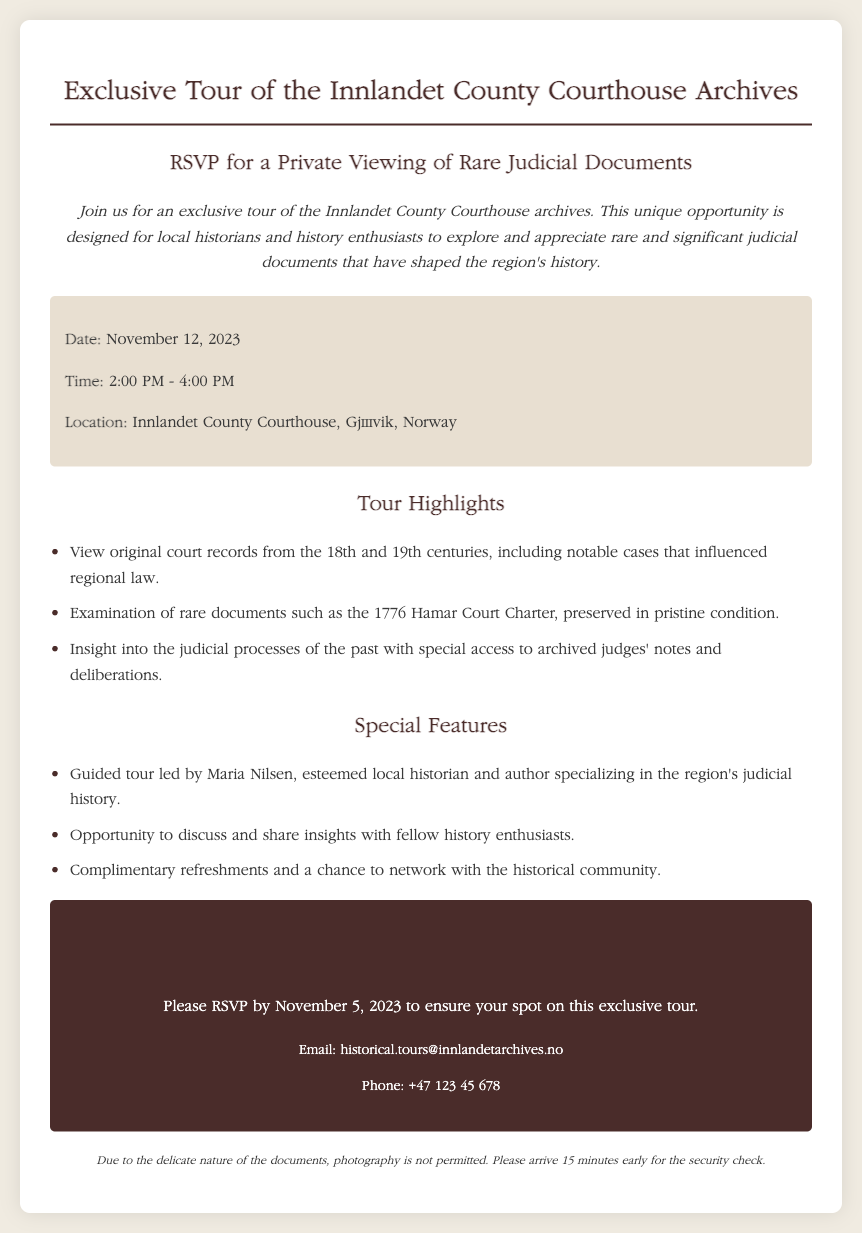what is the date of the tour? The date of the tour is specified in the document under the details section.
Answer: November 12, 2023 what time does the tour start? The starting time is listed in the details section of the RSVP card.
Answer: 2:00 PM who is leading the guided tour? The document identifies the person leading the tour in the special features section.
Answer: Maria Nilsen how long is the tour expected to last? The duration of the tour is indicated by the start and end times mentioned in the details section.
Answer: 2 hours what is not allowed during the tour? The document mentions restrictions on behavior in the note section.
Answer: Photography by when should guests RSVP? The RSVP deadline is provided in the RSVP section of the document.
Answer: November 5, 2023 where is the tour taking place? The location of the tour is specified in the details section.
Answer: Innlandet County Courthouse, Gjøvik, Norway what type of refreshments will be provided? The document mentions complimentary refreshments but does not specify types; this is inferred from the context.
Answer: Complimentary what type of documents will be viewed? The tour highlights section explains the kinds of documents that will be showcased during the tour.
Answer: Judicial documents 